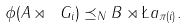<formula> <loc_0><loc_0><loc_500><loc_500>\phi ( A \rtimes \ G _ { i } ) \preceq _ { N } B \rtimes \L a _ { \pi ( i ) } .</formula> 